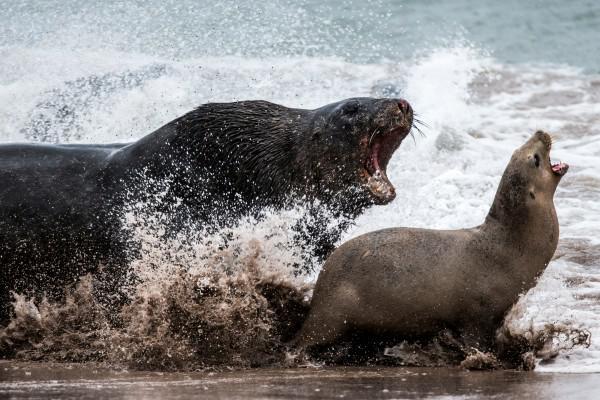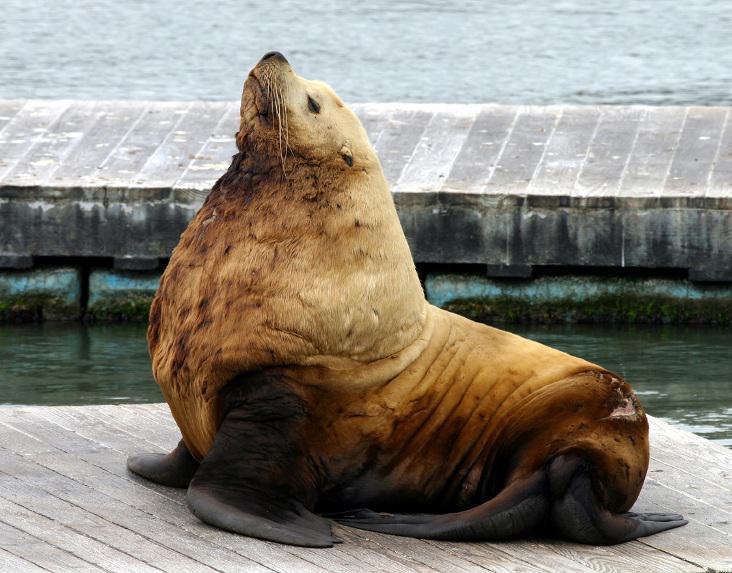The first image is the image on the left, the second image is the image on the right. Examine the images to the left and right. Is the description "Left image shows two seals with upraised heads, one large and dark, and the other smaller and paler." accurate? Answer yes or no. No. 